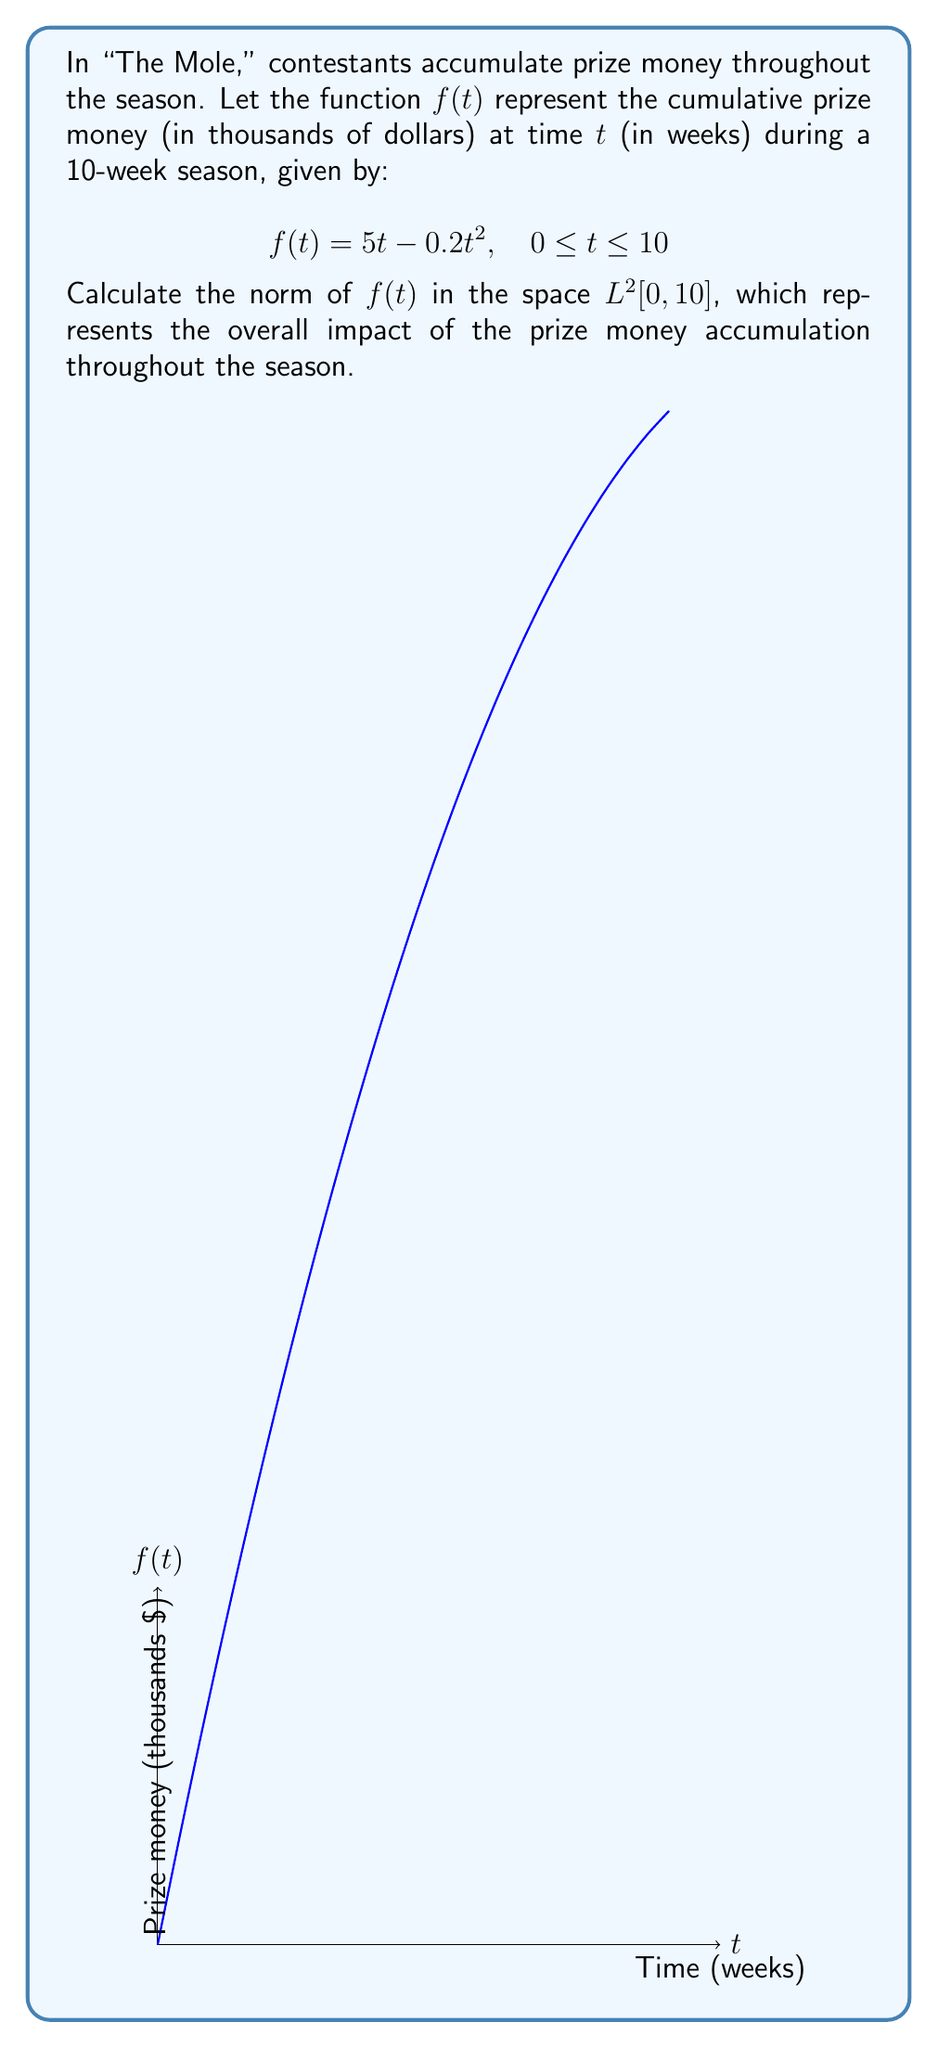Can you solve this math problem? To calculate the norm of $f(t)$ in $L^2[0,10]$, we need to use the formula:

$$\|f\|_{L^2[0,10]} = \left(\int_0^{10} |f(t)|^2 dt\right)^{1/2}$$

Let's proceed step by step:

1) First, we square the function:
   $|f(t)|^2 = (5t - 0.2t^2)^2 = 25t^2 - 2t^3 + 0.04t^4$

2) Now, we integrate this from 0 to 10:
   $$\int_0^{10} (25t^2 - 2t^3 + 0.04t^4) dt$$

3) Integrate each term:
   $$\left[\frac{25t^3}{3} - \frac{2t^4}{4} + \frac{0.04t^5}{5}\right]_0^{10}$$

4) Evaluate at the limits:
   $$\left(\frac{25000}{3} - 500 + 80\right) - (0) = 7913.33$$

5) Take the square root:
   $$\sqrt{7913.33} \approx 88.96$$

Therefore, the norm of $f(t)$ in $L^2[0,10]$ is approximately 88.96.
Answer: $\|f\|_{L^2[0,10]} \approx 88.96$ 